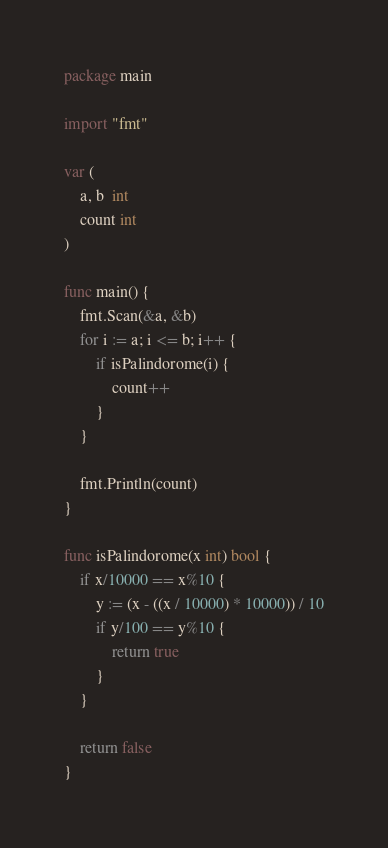Convert code to text. <code><loc_0><loc_0><loc_500><loc_500><_Go_>package main

import "fmt"

var (
	a, b  int
	count int
)

func main() {
	fmt.Scan(&a, &b)
	for i := a; i <= b; i++ {
		if isPalindorome(i) {
			count++
		}
	}

	fmt.Println(count)
}

func isPalindorome(x int) bool {
	if x/10000 == x%10 {
		y := (x - ((x / 10000) * 10000)) / 10
		if y/100 == y%10 {
			return true
		}
	}

	return false
}
</code> 